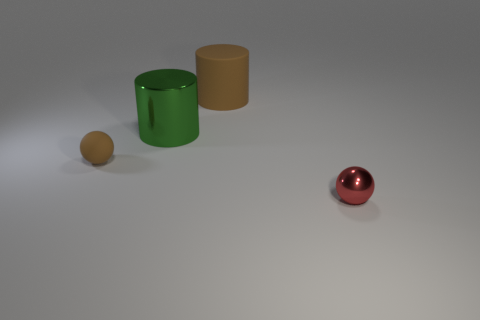There is a rubber object that is the same color as the tiny rubber ball; what is its size?
Make the answer very short. Large. What is the material of the big cylinder that is the same color as the tiny matte sphere?
Provide a short and direct response. Rubber. There is a brown object right of the large green metal thing; what is its size?
Provide a short and direct response. Large. Is there a large shiny block that has the same color as the big metal object?
Your answer should be compact. No. There is a shiny thing that is behind the brown matte sphere; is it the same size as the brown cylinder?
Keep it short and to the point. Yes. What is the color of the big matte cylinder?
Offer a terse response. Brown. The shiny thing that is left of the ball in front of the tiny brown matte sphere is what color?
Offer a very short reply. Green. Is there a big yellow object made of the same material as the big brown cylinder?
Give a very brief answer. No. There is a tiny object to the right of the small ball on the left side of the red shiny ball; what is its material?
Keep it short and to the point. Metal. What number of other cyan metal things have the same shape as the big shiny thing?
Give a very brief answer. 0. 